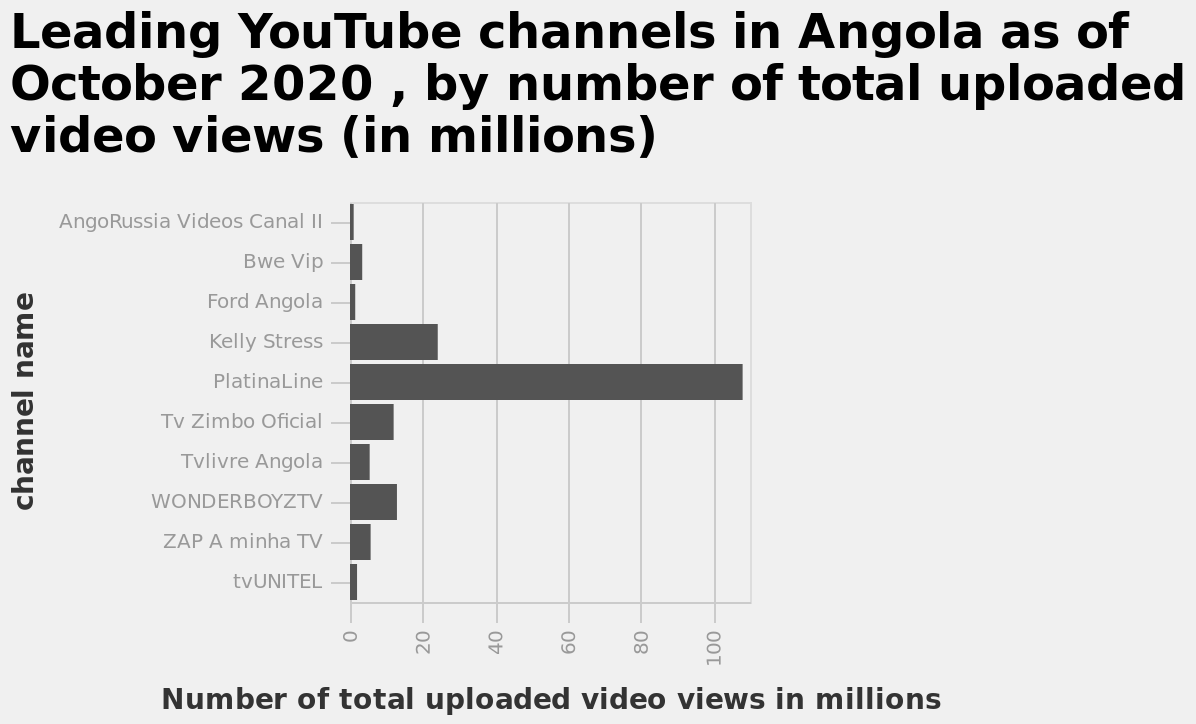<image>
What is the most popular youtube channel in Angola? The most popular youtube channel in Angola is PlatinaLine. please summary the statistics and relations of the chart PlatinaLine is by far the most popular youtube channel in Angolo. Which country has the most popular youtube channel called PlatinaLine? PlatinaLine is the most popular youtube channel in Angola. 